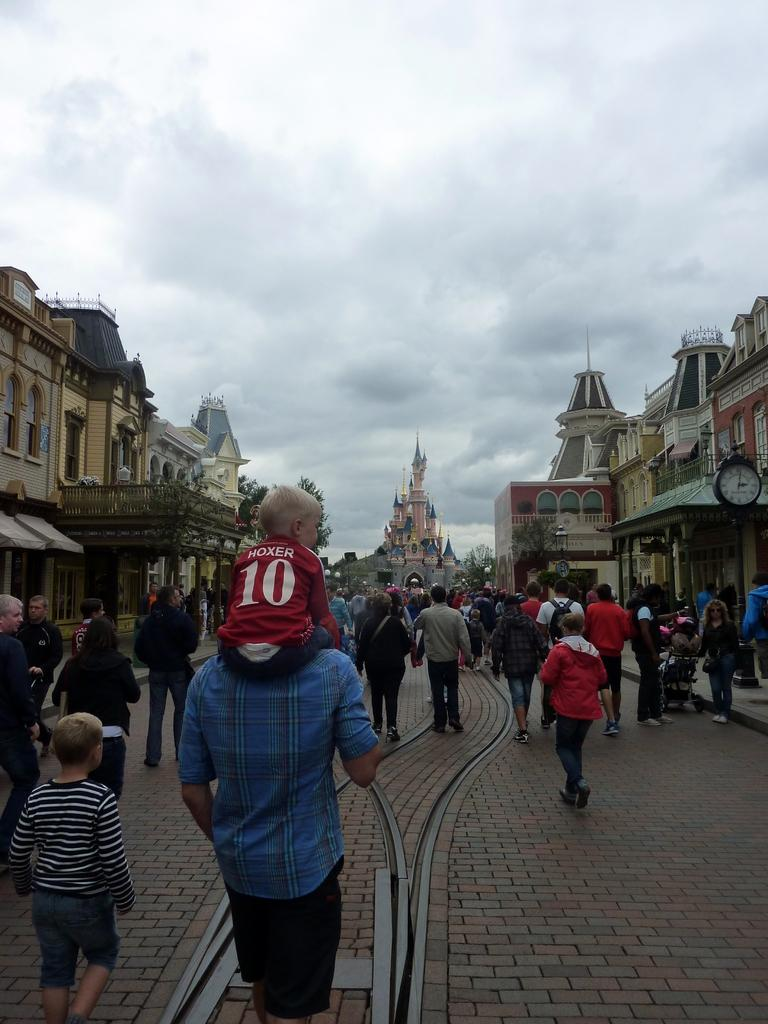What are the people in the image doing? There is a group of people walking on the road in the image. What can be seen in the background of the image? Buildings, trees, and the sky with clouds are visible in the background. Can you describe the clock in the image? Yes, there is a clock in the image. What might be the purpose of the clock in the image? The clock could be used to tell the time or serve as a decorative element. What type of channel can be seen running through the image? There is no channel visible in the image; it features a group of people walking on the road, buildings, trees, a clock, and the sky with clouds. 